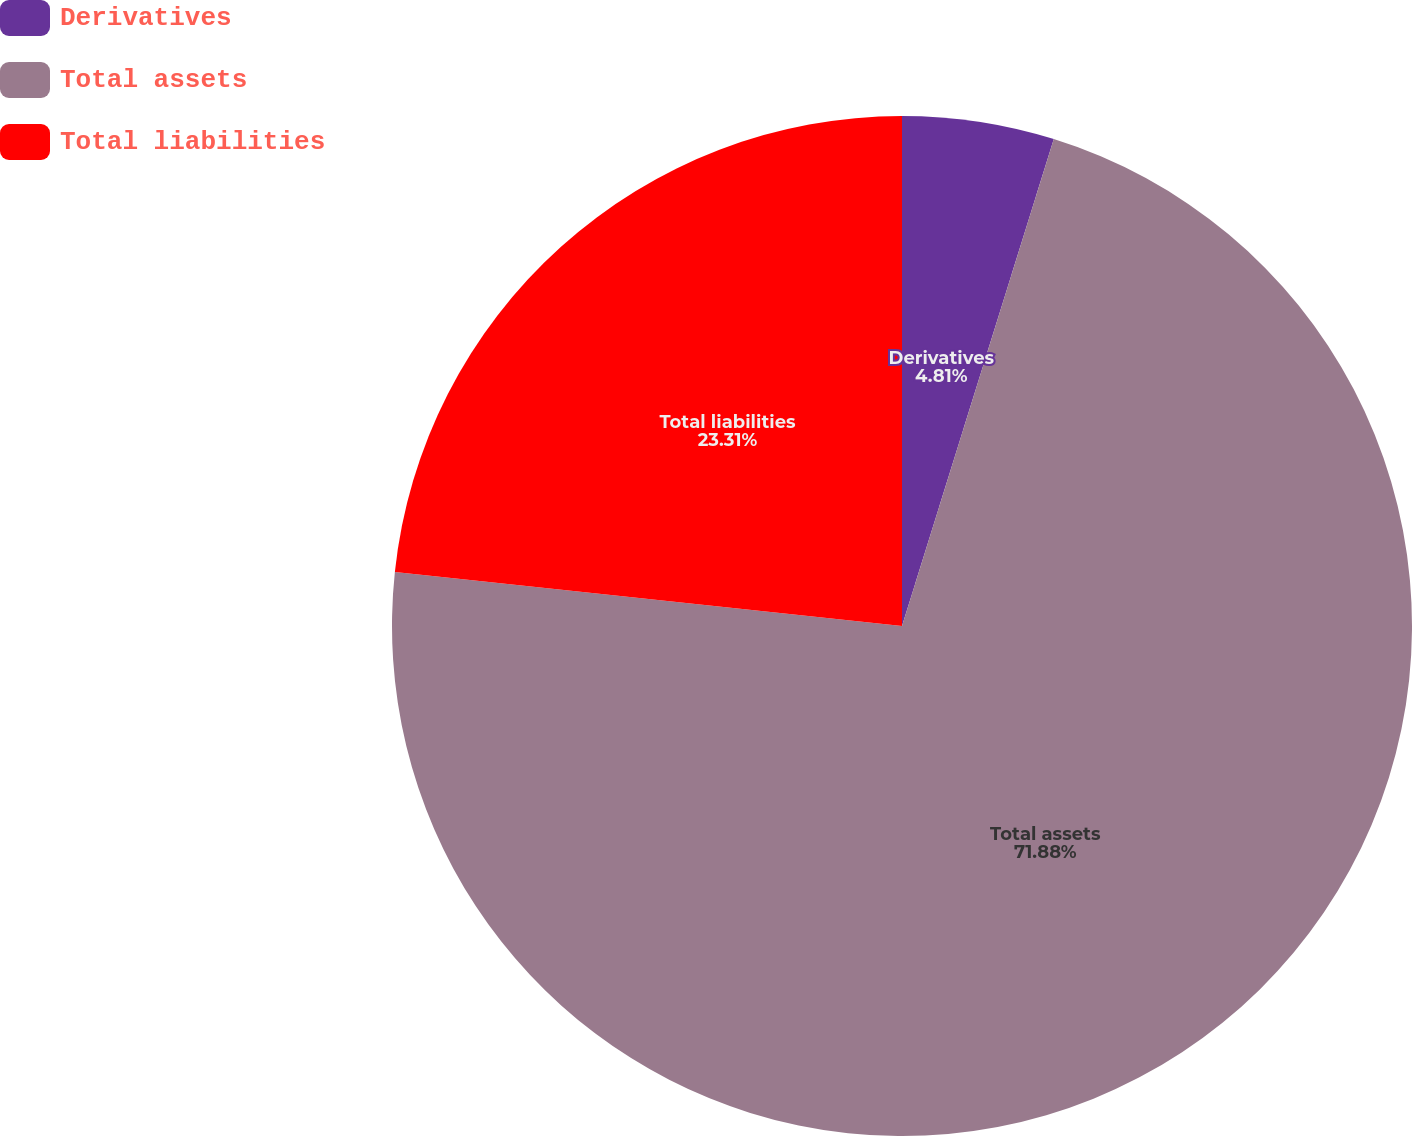Convert chart to OTSL. <chart><loc_0><loc_0><loc_500><loc_500><pie_chart><fcel>Derivatives<fcel>Total assets<fcel>Total liabilities<nl><fcel>4.81%<fcel>71.88%<fcel>23.31%<nl></chart> 